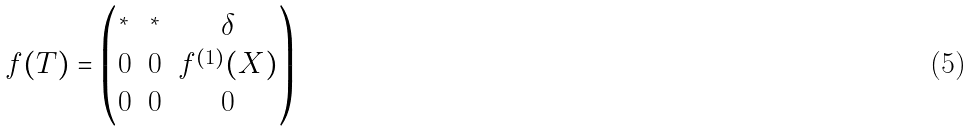Convert formula to latex. <formula><loc_0><loc_0><loc_500><loc_500>f ( T ) = \begin{pmatrix} ^ { * } & ^ { * } & \delta \\ 0 & 0 & f ^ { ( 1 ) } ( X ) \\ 0 & 0 & 0 \end{pmatrix}</formula> 